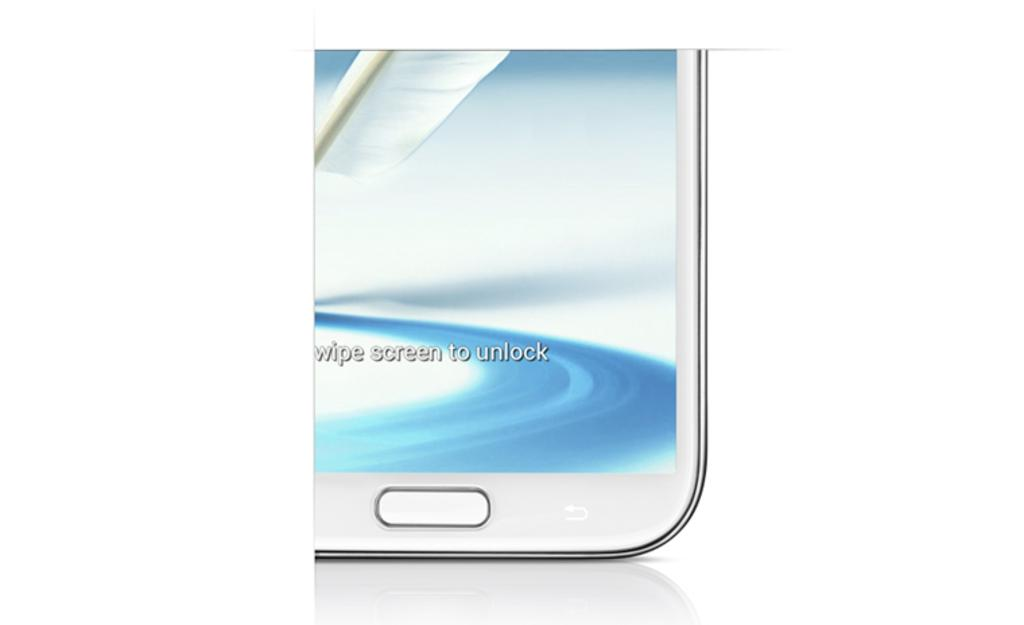<image>
Create a compact narrative representing the image presented. White phone with a screen that says Swipe Screen To Unlock. 